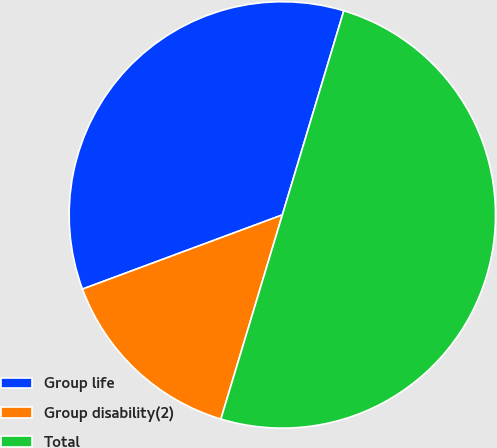<chart> <loc_0><loc_0><loc_500><loc_500><pie_chart><fcel>Group life<fcel>Group disability(2)<fcel>Total<nl><fcel>35.31%<fcel>14.69%<fcel>50.0%<nl></chart> 